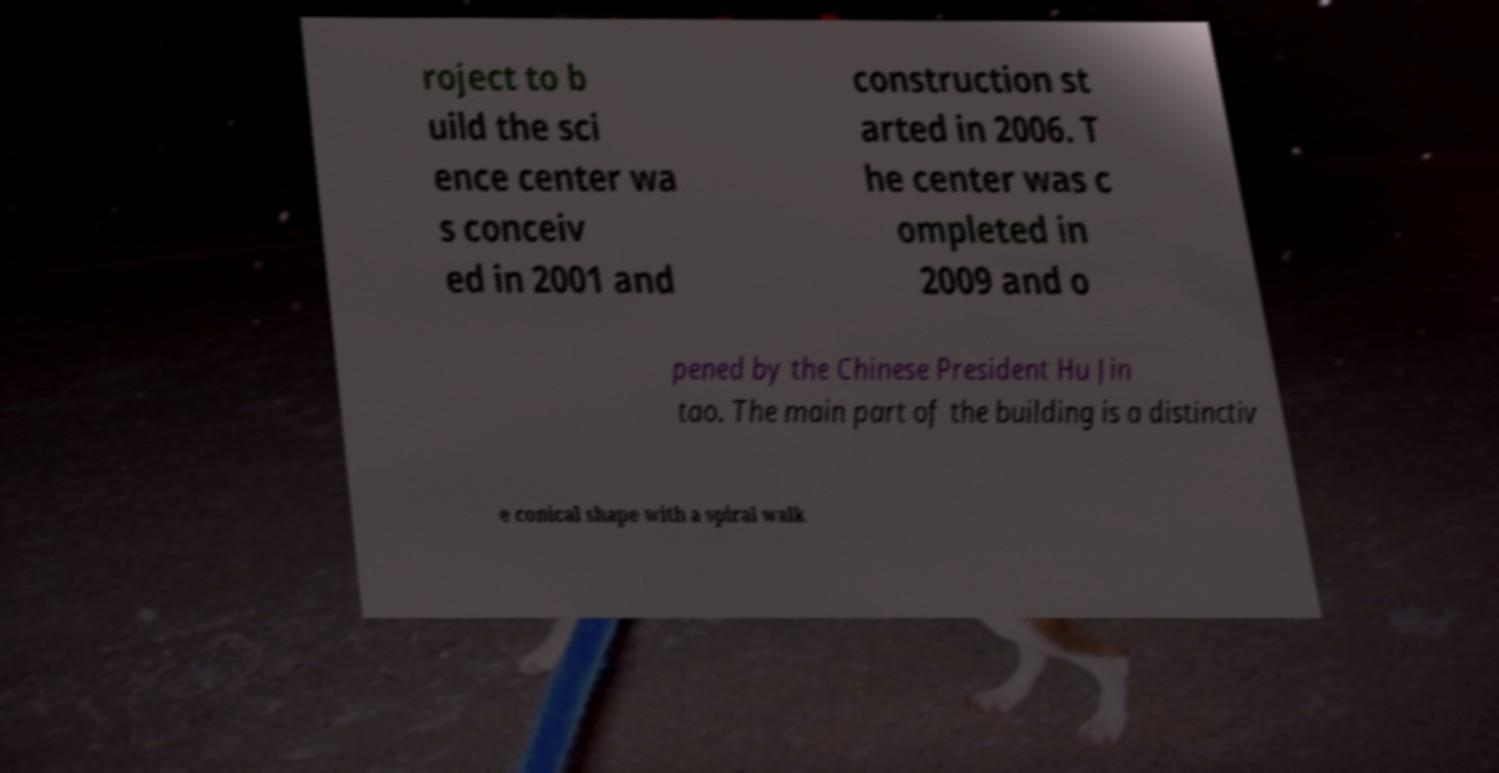Could you assist in decoding the text presented in this image and type it out clearly? roject to b uild the sci ence center wa s conceiv ed in 2001 and construction st arted in 2006. T he center was c ompleted in 2009 and o pened by the Chinese President Hu Jin tao. The main part of the building is a distinctiv e conical shape with a spiral walk 